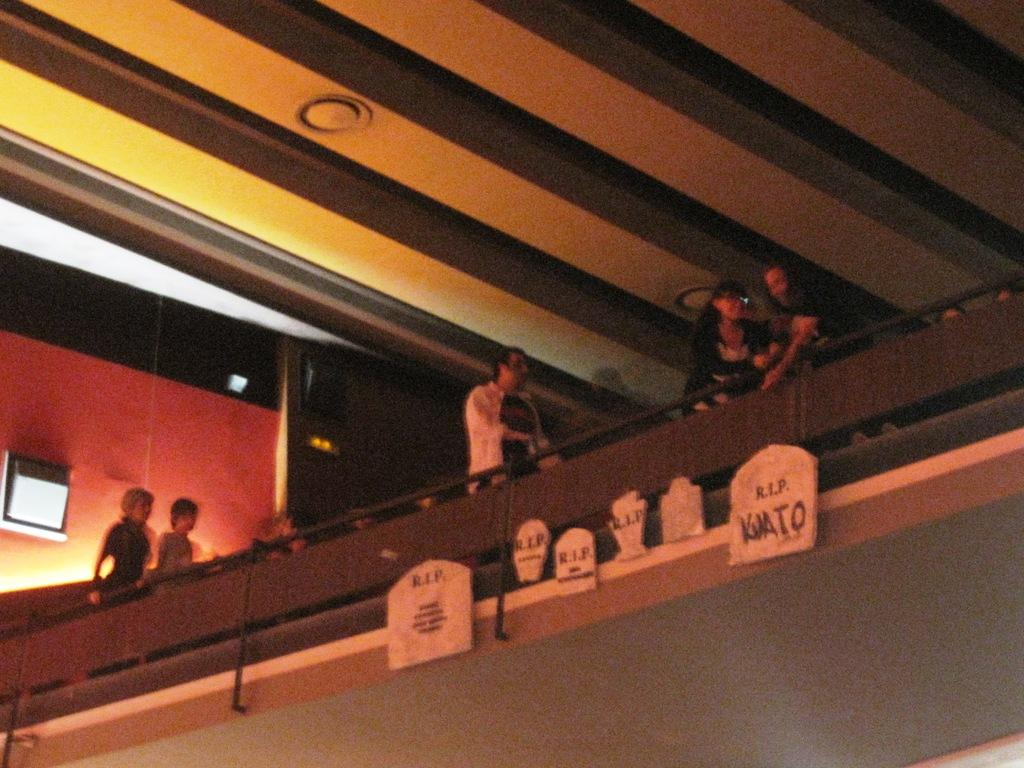What type of boards are visible in the image? There are "rest in peace" boards in the image. How are the boards positioned in the image? The boards are attached to a surface. What can be seen behind the boards? There is a railing behind the boards. Are there any people visible in the image? Yes, there are people standing behind the railing. What type of feast is being prepared behind the railing in the image? There is no feast being prepared in the image; the focus is on the "rest in peace" boards and the people standing behind the railing. 